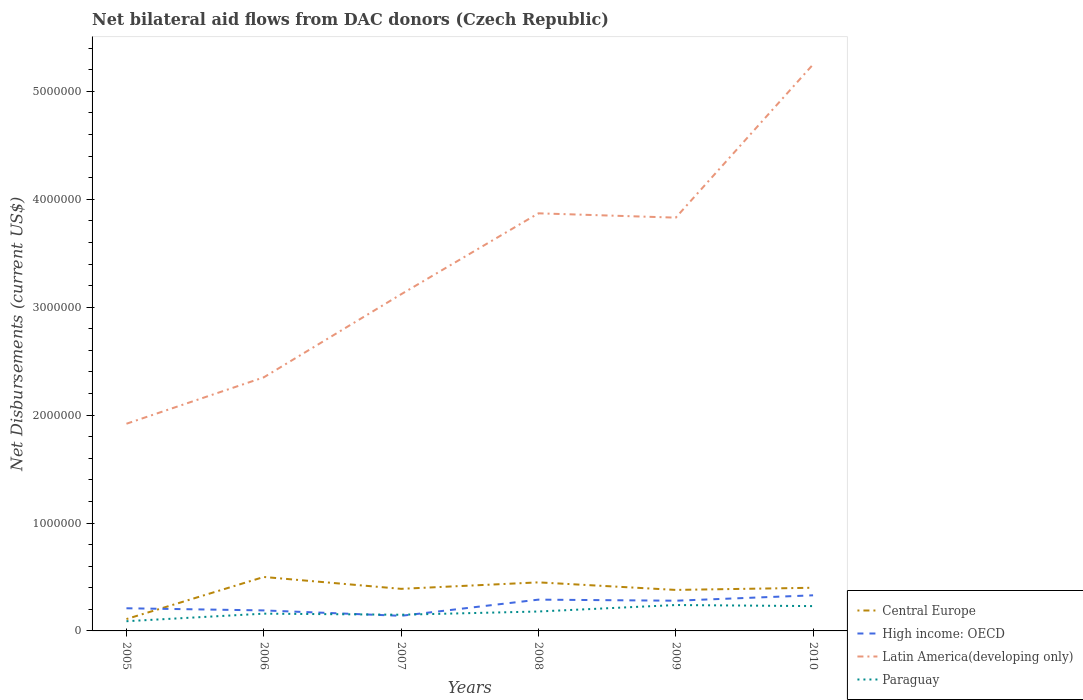How many different coloured lines are there?
Give a very brief answer. 4. Is the number of lines equal to the number of legend labels?
Your answer should be compact. Yes. Across all years, what is the maximum net bilateral aid flows in High income: OECD?
Your answer should be compact. 1.40e+05. What is the total net bilateral aid flows in Latin America(developing only) in the graph?
Offer a very short reply. -1.95e+06. What is the difference between the highest and the lowest net bilateral aid flows in Central Europe?
Your answer should be very brief. 5. Is the net bilateral aid flows in Central Europe strictly greater than the net bilateral aid flows in Latin America(developing only) over the years?
Your answer should be very brief. Yes. Are the values on the major ticks of Y-axis written in scientific E-notation?
Give a very brief answer. No. Does the graph contain any zero values?
Keep it short and to the point. No. Where does the legend appear in the graph?
Give a very brief answer. Bottom right. What is the title of the graph?
Your answer should be compact. Net bilateral aid flows from DAC donors (Czech Republic). What is the label or title of the X-axis?
Ensure brevity in your answer.  Years. What is the label or title of the Y-axis?
Your response must be concise. Net Disbursements (current US$). What is the Net Disbursements (current US$) in High income: OECD in 2005?
Your answer should be very brief. 2.10e+05. What is the Net Disbursements (current US$) in Latin America(developing only) in 2005?
Keep it short and to the point. 1.92e+06. What is the Net Disbursements (current US$) of Paraguay in 2005?
Provide a short and direct response. 9.00e+04. What is the Net Disbursements (current US$) of Latin America(developing only) in 2006?
Provide a short and direct response. 2.35e+06. What is the Net Disbursements (current US$) of Paraguay in 2006?
Your response must be concise. 1.60e+05. What is the Net Disbursements (current US$) in Central Europe in 2007?
Offer a very short reply. 3.90e+05. What is the Net Disbursements (current US$) of Latin America(developing only) in 2007?
Your answer should be very brief. 3.12e+06. What is the Net Disbursements (current US$) of Paraguay in 2007?
Provide a short and direct response. 1.50e+05. What is the Net Disbursements (current US$) in Latin America(developing only) in 2008?
Your answer should be compact. 3.87e+06. What is the Net Disbursements (current US$) in Paraguay in 2008?
Provide a succinct answer. 1.80e+05. What is the Net Disbursements (current US$) of Latin America(developing only) in 2009?
Your answer should be compact. 3.83e+06. What is the Net Disbursements (current US$) in Central Europe in 2010?
Keep it short and to the point. 4.00e+05. What is the Net Disbursements (current US$) of High income: OECD in 2010?
Your answer should be very brief. 3.30e+05. What is the Net Disbursements (current US$) in Latin America(developing only) in 2010?
Provide a succinct answer. 5.25e+06. Across all years, what is the maximum Net Disbursements (current US$) in Latin America(developing only)?
Ensure brevity in your answer.  5.25e+06. Across all years, what is the minimum Net Disbursements (current US$) of High income: OECD?
Your answer should be very brief. 1.40e+05. Across all years, what is the minimum Net Disbursements (current US$) of Latin America(developing only)?
Keep it short and to the point. 1.92e+06. What is the total Net Disbursements (current US$) in Central Europe in the graph?
Offer a very short reply. 2.23e+06. What is the total Net Disbursements (current US$) in High income: OECD in the graph?
Ensure brevity in your answer.  1.44e+06. What is the total Net Disbursements (current US$) in Latin America(developing only) in the graph?
Your answer should be compact. 2.03e+07. What is the total Net Disbursements (current US$) in Paraguay in the graph?
Ensure brevity in your answer.  1.05e+06. What is the difference between the Net Disbursements (current US$) in Central Europe in 2005 and that in 2006?
Make the answer very short. -3.90e+05. What is the difference between the Net Disbursements (current US$) in Latin America(developing only) in 2005 and that in 2006?
Offer a terse response. -4.30e+05. What is the difference between the Net Disbursements (current US$) of Central Europe in 2005 and that in 2007?
Offer a very short reply. -2.80e+05. What is the difference between the Net Disbursements (current US$) of Latin America(developing only) in 2005 and that in 2007?
Offer a terse response. -1.20e+06. What is the difference between the Net Disbursements (current US$) in Paraguay in 2005 and that in 2007?
Provide a succinct answer. -6.00e+04. What is the difference between the Net Disbursements (current US$) of High income: OECD in 2005 and that in 2008?
Ensure brevity in your answer.  -8.00e+04. What is the difference between the Net Disbursements (current US$) of Latin America(developing only) in 2005 and that in 2008?
Offer a terse response. -1.95e+06. What is the difference between the Net Disbursements (current US$) in Paraguay in 2005 and that in 2008?
Provide a succinct answer. -9.00e+04. What is the difference between the Net Disbursements (current US$) in Central Europe in 2005 and that in 2009?
Your answer should be very brief. -2.70e+05. What is the difference between the Net Disbursements (current US$) in High income: OECD in 2005 and that in 2009?
Offer a terse response. -7.00e+04. What is the difference between the Net Disbursements (current US$) of Latin America(developing only) in 2005 and that in 2009?
Provide a short and direct response. -1.91e+06. What is the difference between the Net Disbursements (current US$) in Latin America(developing only) in 2005 and that in 2010?
Your response must be concise. -3.33e+06. What is the difference between the Net Disbursements (current US$) of Central Europe in 2006 and that in 2007?
Your answer should be compact. 1.10e+05. What is the difference between the Net Disbursements (current US$) in Latin America(developing only) in 2006 and that in 2007?
Offer a terse response. -7.70e+05. What is the difference between the Net Disbursements (current US$) in Central Europe in 2006 and that in 2008?
Keep it short and to the point. 5.00e+04. What is the difference between the Net Disbursements (current US$) of Latin America(developing only) in 2006 and that in 2008?
Provide a succinct answer. -1.52e+06. What is the difference between the Net Disbursements (current US$) of Central Europe in 2006 and that in 2009?
Provide a succinct answer. 1.20e+05. What is the difference between the Net Disbursements (current US$) of High income: OECD in 2006 and that in 2009?
Ensure brevity in your answer.  -9.00e+04. What is the difference between the Net Disbursements (current US$) in Latin America(developing only) in 2006 and that in 2009?
Make the answer very short. -1.48e+06. What is the difference between the Net Disbursements (current US$) in Central Europe in 2006 and that in 2010?
Give a very brief answer. 1.00e+05. What is the difference between the Net Disbursements (current US$) of High income: OECD in 2006 and that in 2010?
Your response must be concise. -1.40e+05. What is the difference between the Net Disbursements (current US$) of Latin America(developing only) in 2006 and that in 2010?
Keep it short and to the point. -2.90e+06. What is the difference between the Net Disbursements (current US$) in Paraguay in 2006 and that in 2010?
Your response must be concise. -7.00e+04. What is the difference between the Net Disbursements (current US$) in Latin America(developing only) in 2007 and that in 2008?
Provide a short and direct response. -7.50e+05. What is the difference between the Net Disbursements (current US$) of Central Europe in 2007 and that in 2009?
Your response must be concise. 10000. What is the difference between the Net Disbursements (current US$) in High income: OECD in 2007 and that in 2009?
Give a very brief answer. -1.40e+05. What is the difference between the Net Disbursements (current US$) in Latin America(developing only) in 2007 and that in 2009?
Your answer should be compact. -7.10e+05. What is the difference between the Net Disbursements (current US$) of Latin America(developing only) in 2007 and that in 2010?
Your answer should be very brief. -2.13e+06. What is the difference between the Net Disbursements (current US$) in Paraguay in 2007 and that in 2010?
Provide a succinct answer. -8.00e+04. What is the difference between the Net Disbursements (current US$) in Central Europe in 2008 and that in 2009?
Keep it short and to the point. 7.00e+04. What is the difference between the Net Disbursements (current US$) in High income: OECD in 2008 and that in 2010?
Your response must be concise. -4.00e+04. What is the difference between the Net Disbursements (current US$) of Latin America(developing only) in 2008 and that in 2010?
Make the answer very short. -1.38e+06. What is the difference between the Net Disbursements (current US$) of Paraguay in 2008 and that in 2010?
Make the answer very short. -5.00e+04. What is the difference between the Net Disbursements (current US$) in Central Europe in 2009 and that in 2010?
Offer a very short reply. -2.00e+04. What is the difference between the Net Disbursements (current US$) in Latin America(developing only) in 2009 and that in 2010?
Make the answer very short. -1.42e+06. What is the difference between the Net Disbursements (current US$) of Paraguay in 2009 and that in 2010?
Provide a succinct answer. 10000. What is the difference between the Net Disbursements (current US$) in Central Europe in 2005 and the Net Disbursements (current US$) in Latin America(developing only) in 2006?
Provide a short and direct response. -2.24e+06. What is the difference between the Net Disbursements (current US$) of Central Europe in 2005 and the Net Disbursements (current US$) of Paraguay in 2006?
Offer a terse response. -5.00e+04. What is the difference between the Net Disbursements (current US$) of High income: OECD in 2005 and the Net Disbursements (current US$) of Latin America(developing only) in 2006?
Your answer should be compact. -2.14e+06. What is the difference between the Net Disbursements (current US$) in High income: OECD in 2005 and the Net Disbursements (current US$) in Paraguay in 2006?
Ensure brevity in your answer.  5.00e+04. What is the difference between the Net Disbursements (current US$) of Latin America(developing only) in 2005 and the Net Disbursements (current US$) of Paraguay in 2006?
Give a very brief answer. 1.76e+06. What is the difference between the Net Disbursements (current US$) of Central Europe in 2005 and the Net Disbursements (current US$) of Latin America(developing only) in 2007?
Make the answer very short. -3.01e+06. What is the difference between the Net Disbursements (current US$) of Central Europe in 2005 and the Net Disbursements (current US$) of Paraguay in 2007?
Provide a succinct answer. -4.00e+04. What is the difference between the Net Disbursements (current US$) of High income: OECD in 2005 and the Net Disbursements (current US$) of Latin America(developing only) in 2007?
Ensure brevity in your answer.  -2.91e+06. What is the difference between the Net Disbursements (current US$) in Latin America(developing only) in 2005 and the Net Disbursements (current US$) in Paraguay in 2007?
Provide a short and direct response. 1.77e+06. What is the difference between the Net Disbursements (current US$) of Central Europe in 2005 and the Net Disbursements (current US$) of Latin America(developing only) in 2008?
Provide a succinct answer. -3.76e+06. What is the difference between the Net Disbursements (current US$) in High income: OECD in 2005 and the Net Disbursements (current US$) in Latin America(developing only) in 2008?
Ensure brevity in your answer.  -3.66e+06. What is the difference between the Net Disbursements (current US$) in Latin America(developing only) in 2005 and the Net Disbursements (current US$) in Paraguay in 2008?
Your answer should be very brief. 1.74e+06. What is the difference between the Net Disbursements (current US$) of Central Europe in 2005 and the Net Disbursements (current US$) of Latin America(developing only) in 2009?
Your answer should be very brief. -3.72e+06. What is the difference between the Net Disbursements (current US$) of High income: OECD in 2005 and the Net Disbursements (current US$) of Latin America(developing only) in 2009?
Offer a very short reply. -3.62e+06. What is the difference between the Net Disbursements (current US$) of Latin America(developing only) in 2005 and the Net Disbursements (current US$) of Paraguay in 2009?
Provide a short and direct response. 1.68e+06. What is the difference between the Net Disbursements (current US$) in Central Europe in 2005 and the Net Disbursements (current US$) in High income: OECD in 2010?
Provide a short and direct response. -2.20e+05. What is the difference between the Net Disbursements (current US$) of Central Europe in 2005 and the Net Disbursements (current US$) of Latin America(developing only) in 2010?
Your answer should be very brief. -5.14e+06. What is the difference between the Net Disbursements (current US$) in Central Europe in 2005 and the Net Disbursements (current US$) in Paraguay in 2010?
Provide a succinct answer. -1.20e+05. What is the difference between the Net Disbursements (current US$) of High income: OECD in 2005 and the Net Disbursements (current US$) of Latin America(developing only) in 2010?
Your answer should be compact. -5.04e+06. What is the difference between the Net Disbursements (current US$) of Latin America(developing only) in 2005 and the Net Disbursements (current US$) of Paraguay in 2010?
Provide a succinct answer. 1.69e+06. What is the difference between the Net Disbursements (current US$) of Central Europe in 2006 and the Net Disbursements (current US$) of High income: OECD in 2007?
Ensure brevity in your answer.  3.60e+05. What is the difference between the Net Disbursements (current US$) in Central Europe in 2006 and the Net Disbursements (current US$) in Latin America(developing only) in 2007?
Provide a short and direct response. -2.62e+06. What is the difference between the Net Disbursements (current US$) in High income: OECD in 2006 and the Net Disbursements (current US$) in Latin America(developing only) in 2007?
Offer a terse response. -2.93e+06. What is the difference between the Net Disbursements (current US$) of Latin America(developing only) in 2006 and the Net Disbursements (current US$) of Paraguay in 2007?
Your response must be concise. 2.20e+06. What is the difference between the Net Disbursements (current US$) of Central Europe in 2006 and the Net Disbursements (current US$) of High income: OECD in 2008?
Your response must be concise. 2.10e+05. What is the difference between the Net Disbursements (current US$) of Central Europe in 2006 and the Net Disbursements (current US$) of Latin America(developing only) in 2008?
Give a very brief answer. -3.37e+06. What is the difference between the Net Disbursements (current US$) of Central Europe in 2006 and the Net Disbursements (current US$) of Paraguay in 2008?
Keep it short and to the point. 3.20e+05. What is the difference between the Net Disbursements (current US$) in High income: OECD in 2006 and the Net Disbursements (current US$) in Latin America(developing only) in 2008?
Your response must be concise. -3.68e+06. What is the difference between the Net Disbursements (current US$) in High income: OECD in 2006 and the Net Disbursements (current US$) in Paraguay in 2008?
Your answer should be compact. 10000. What is the difference between the Net Disbursements (current US$) in Latin America(developing only) in 2006 and the Net Disbursements (current US$) in Paraguay in 2008?
Your answer should be very brief. 2.17e+06. What is the difference between the Net Disbursements (current US$) of Central Europe in 2006 and the Net Disbursements (current US$) of High income: OECD in 2009?
Your answer should be compact. 2.20e+05. What is the difference between the Net Disbursements (current US$) of Central Europe in 2006 and the Net Disbursements (current US$) of Latin America(developing only) in 2009?
Your answer should be compact. -3.33e+06. What is the difference between the Net Disbursements (current US$) of High income: OECD in 2006 and the Net Disbursements (current US$) of Latin America(developing only) in 2009?
Make the answer very short. -3.64e+06. What is the difference between the Net Disbursements (current US$) in High income: OECD in 2006 and the Net Disbursements (current US$) in Paraguay in 2009?
Offer a very short reply. -5.00e+04. What is the difference between the Net Disbursements (current US$) of Latin America(developing only) in 2006 and the Net Disbursements (current US$) of Paraguay in 2009?
Make the answer very short. 2.11e+06. What is the difference between the Net Disbursements (current US$) in Central Europe in 2006 and the Net Disbursements (current US$) in High income: OECD in 2010?
Offer a very short reply. 1.70e+05. What is the difference between the Net Disbursements (current US$) of Central Europe in 2006 and the Net Disbursements (current US$) of Latin America(developing only) in 2010?
Keep it short and to the point. -4.75e+06. What is the difference between the Net Disbursements (current US$) in High income: OECD in 2006 and the Net Disbursements (current US$) in Latin America(developing only) in 2010?
Ensure brevity in your answer.  -5.06e+06. What is the difference between the Net Disbursements (current US$) in High income: OECD in 2006 and the Net Disbursements (current US$) in Paraguay in 2010?
Provide a short and direct response. -4.00e+04. What is the difference between the Net Disbursements (current US$) in Latin America(developing only) in 2006 and the Net Disbursements (current US$) in Paraguay in 2010?
Provide a short and direct response. 2.12e+06. What is the difference between the Net Disbursements (current US$) in Central Europe in 2007 and the Net Disbursements (current US$) in High income: OECD in 2008?
Make the answer very short. 1.00e+05. What is the difference between the Net Disbursements (current US$) in Central Europe in 2007 and the Net Disbursements (current US$) in Latin America(developing only) in 2008?
Give a very brief answer. -3.48e+06. What is the difference between the Net Disbursements (current US$) of High income: OECD in 2007 and the Net Disbursements (current US$) of Latin America(developing only) in 2008?
Your response must be concise. -3.73e+06. What is the difference between the Net Disbursements (current US$) in Latin America(developing only) in 2007 and the Net Disbursements (current US$) in Paraguay in 2008?
Give a very brief answer. 2.94e+06. What is the difference between the Net Disbursements (current US$) of Central Europe in 2007 and the Net Disbursements (current US$) of High income: OECD in 2009?
Your answer should be very brief. 1.10e+05. What is the difference between the Net Disbursements (current US$) in Central Europe in 2007 and the Net Disbursements (current US$) in Latin America(developing only) in 2009?
Keep it short and to the point. -3.44e+06. What is the difference between the Net Disbursements (current US$) in Central Europe in 2007 and the Net Disbursements (current US$) in Paraguay in 2009?
Provide a succinct answer. 1.50e+05. What is the difference between the Net Disbursements (current US$) of High income: OECD in 2007 and the Net Disbursements (current US$) of Latin America(developing only) in 2009?
Give a very brief answer. -3.69e+06. What is the difference between the Net Disbursements (current US$) in Latin America(developing only) in 2007 and the Net Disbursements (current US$) in Paraguay in 2009?
Your response must be concise. 2.88e+06. What is the difference between the Net Disbursements (current US$) of Central Europe in 2007 and the Net Disbursements (current US$) of Latin America(developing only) in 2010?
Offer a terse response. -4.86e+06. What is the difference between the Net Disbursements (current US$) of High income: OECD in 2007 and the Net Disbursements (current US$) of Latin America(developing only) in 2010?
Provide a succinct answer. -5.11e+06. What is the difference between the Net Disbursements (current US$) in High income: OECD in 2007 and the Net Disbursements (current US$) in Paraguay in 2010?
Your response must be concise. -9.00e+04. What is the difference between the Net Disbursements (current US$) of Latin America(developing only) in 2007 and the Net Disbursements (current US$) of Paraguay in 2010?
Your answer should be very brief. 2.89e+06. What is the difference between the Net Disbursements (current US$) of Central Europe in 2008 and the Net Disbursements (current US$) of Latin America(developing only) in 2009?
Offer a terse response. -3.38e+06. What is the difference between the Net Disbursements (current US$) in High income: OECD in 2008 and the Net Disbursements (current US$) in Latin America(developing only) in 2009?
Make the answer very short. -3.54e+06. What is the difference between the Net Disbursements (current US$) of High income: OECD in 2008 and the Net Disbursements (current US$) of Paraguay in 2009?
Ensure brevity in your answer.  5.00e+04. What is the difference between the Net Disbursements (current US$) of Latin America(developing only) in 2008 and the Net Disbursements (current US$) of Paraguay in 2009?
Provide a succinct answer. 3.63e+06. What is the difference between the Net Disbursements (current US$) in Central Europe in 2008 and the Net Disbursements (current US$) in High income: OECD in 2010?
Offer a very short reply. 1.20e+05. What is the difference between the Net Disbursements (current US$) of Central Europe in 2008 and the Net Disbursements (current US$) of Latin America(developing only) in 2010?
Offer a terse response. -4.80e+06. What is the difference between the Net Disbursements (current US$) of Central Europe in 2008 and the Net Disbursements (current US$) of Paraguay in 2010?
Your response must be concise. 2.20e+05. What is the difference between the Net Disbursements (current US$) in High income: OECD in 2008 and the Net Disbursements (current US$) in Latin America(developing only) in 2010?
Offer a very short reply. -4.96e+06. What is the difference between the Net Disbursements (current US$) in Latin America(developing only) in 2008 and the Net Disbursements (current US$) in Paraguay in 2010?
Your answer should be compact. 3.64e+06. What is the difference between the Net Disbursements (current US$) of Central Europe in 2009 and the Net Disbursements (current US$) of Latin America(developing only) in 2010?
Your answer should be very brief. -4.87e+06. What is the difference between the Net Disbursements (current US$) in Central Europe in 2009 and the Net Disbursements (current US$) in Paraguay in 2010?
Provide a succinct answer. 1.50e+05. What is the difference between the Net Disbursements (current US$) in High income: OECD in 2009 and the Net Disbursements (current US$) in Latin America(developing only) in 2010?
Your answer should be compact. -4.97e+06. What is the difference between the Net Disbursements (current US$) in Latin America(developing only) in 2009 and the Net Disbursements (current US$) in Paraguay in 2010?
Provide a succinct answer. 3.60e+06. What is the average Net Disbursements (current US$) of Central Europe per year?
Offer a terse response. 3.72e+05. What is the average Net Disbursements (current US$) in Latin America(developing only) per year?
Ensure brevity in your answer.  3.39e+06. What is the average Net Disbursements (current US$) of Paraguay per year?
Your answer should be compact. 1.75e+05. In the year 2005, what is the difference between the Net Disbursements (current US$) in Central Europe and Net Disbursements (current US$) in Latin America(developing only)?
Your response must be concise. -1.81e+06. In the year 2005, what is the difference between the Net Disbursements (current US$) of High income: OECD and Net Disbursements (current US$) of Latin America(developing only)?
Offer a terse response. -1.71e+06. In the year 2005, what is the difference between the Net Disbursements (current US$) in Latin America(developing only) and Net Disbursements (current US$) in Paraguay?
Provide a short and direct response. 1.83e+06. In the year 2006, what is the difference between the Net Disbursements (current US$) in Central Europe and Net Disbursements (current US$) in High income: OECD?
Your answer should be very brief. 3.10e+05. In the year 2006, what is the difference between the Net Disbursements (current US$) of Central Europe and Net Disbursements (current US$) of Latin America(developing only)?
Offer a terse response. -1.85e+06. In the year 2006, what is the difference between the Net Disbursements (current US$) in Central Europe and Net Disbursements (current US$) in Paraguay?
Provide a succinct answer. 3.40e+05. In the year 2006, what is the difference between the Net Disbursements (current US$) of High income: OECD and Net Disbursements (current US$) of Latin America(developing only)?
Ensure brevity in your answer.  -2.16e+06. In the year 2006, what is the difference between the Net Disbursements (current US$) in High income: OECD and Net Disbursements (current US$) in Paraguay?
Your answer should be very brief. 3.00e+04. In the year 2006, what is the difference between the Net Disbursements (current US$) in Latin America(developing only) and Net Disbursements (current US$) in Paraguay?
Keep it short and to the point. 2.19e+06. In the year 2007, what is the difference between the Net Disbursements (current US$) in Central Europe and Net Disbursements (current US$) in High income: OECD?
Keep it short and to the point. 2.50e+05. In the year 2007, what is the difference between the Net Disbursements (current US$) in Central Europe and Net Disbursements (current US$) in Latin America(developing only)?
Keep it short and to the point. -2.73e+06. In the year 2007, what is the difference between the Net Disbursements (current US$) of High income: OECD and Net Disbursements (current US$) of Latin America(developing only)?
Your response must be concise. -2.98e+06. In the year 2007, what is the difference between the Net Disbursements (current US$) in High income: OECD and Net Disbursements (current US$) in Paraguay?
Give a very brief answer. -10000. In the year 2007, what is the difference between the Net Disbursements (current US$) of Latin America(developing only) and Net Disbursements (current US$) of Paraguay?
Offer a terse response. 2.97e+06. In the year 2008, what is the difference between the Net Disbursements (current US$) of Central Europe and Net Disbursements (current US$) of Latin America(developing only)?
Provide a short and direct response. -3.42e+06. In the year 2008, what is the difference between the Net Disbursements (current US$) in Central Europe and Net Disbursements (current US$) in Paraguay?
Your answer should be compact. 2.70e+05. In the year 2008, what is the difference between the Net Disbursements (current US$) in High income: OECD and Net Disbursements (current US$) in Latin America(developing only)?
Make the answer very short. -3.58e+06. In the year 2008, what is the difference between the Net Disbursements (current US$) of Latin America(developing only) and Net Disbursements (current US$) of Paraguay?
Keep it short and to the point. 3.69e+06. In the year 2009, what is the difference between the Net Disbursements (current US$) in Central Europe and Net Disbursements (current US$) in High income: OECD?
Keep it short and to the point. 1.00e+05. In the year 2009, what is the difference between the Net Disbursements (current US$) of Central Europe and Net Disbursements (current US$) of Latin America(developing only)?
Give a very brief answer. -3.45e+06. In the year 2009, what is the difference between the Net Disbursements (current US$) in High income: OECD and Net Disbursements (current US$) in Latin America(developing only)?
Ensure brevity in your answer.  -3.55e+06. In the year 2009, what is the difference between the Net Disbursements (current US$) of Latin America(developing only) and Net Disbursements (current US$) of Paraguay?
Your answer should be very brief. 3.59e+06. In the year 2010, what is the difference between the Net Disbursements (current US$) of Central Europe and Net Disbursements (current US$) of High income: OECD?
Your answer should be very brief. 7.00e+04. In the year 2010, what is the difference between the Net Disbursements (current US$) in Central Europe and Net Disbursements (current US$) in Latin America(developing only)?
Give a very brief answer. -4.85e+06. In the year 2010, what is the difference between the Net Disbursements (current US$) in High income: OECD and Net Disbursements (current US$) in Latin America(developing only)?
Give a very brief answer. -4.92e+06. In the year 2010, what is the difference between the Net Disbursements (current US$) in High income: OECD and Net Disbursements (current US$) in Paraguay?
Offer a very short reply. 1.00e+05. In the year 2010, what is the difference between the Net Disbursements (current US$) in Latin America(developing only) and Net Disbursements (current US$) in Paraguay?
Offer a terse response. 5.02e+06. What is the ratio of the Net Disbursements (current US$) of Central Europe in 2005 to that in 2006?
Provide a succinct answer. 0.22. What is the ratio of the Net Disbursements (current US$) of High income: OECD in 2005 to that in 2006?
Make the answer very short. 1.11. What is the ratio of the Net Disbursements (current US$) of Latin America(developing only) in 2005 to that in 2006?
Give a very brief answer. 0.82. What is the ratio of the Net Disbursements (current US$) of Paraguay in 2005 to that in 2006?
Offer a terse response. 0.56. What is the ratio of the Net Disbursements (current US$) in Central Europe in 2005 to that in 2007?
Your answer should be very brief. 0.28. What is the ratio of the Net Disbursements (current US$) of High income: OECD in 2005 to that in 2007?
Your answer should be very brief. 1.5. What is the ratio of the Net Disbursements (current US$) in Latin America(developing only) in 2005 to that in 2007?
Your answer should be compact. 0.62. What is the ratio of the Net Disbursements (current US$) of Central Europe in 2005 to that in 2008?
Provide a short and direct response. 0.24. What is the ratio of the Net Disbursements (current US$) of High income: OECD in 2005 to that in 2008?
Provide a short and direct response. 0.72. What is the ratio of the Net Disbursements (current US$) of Latin America(developing only) in 2005 to that in 2008?
Your answer should be very brief. 0.5. What is the ratio of the Net Disbursements (current US$) in Paraguay in 2005 to that in 2008?
Provide a short and direct response. 0.5. What is the ratio of the Net Disbursements (current US$) in Central Europe in 2005 to that in 2009?
Ensure brevity in your answer.  0.29. What is the ratio of the Net Disbursements (current US$) of Latin America(developing only) in 2005 to that in 2009?
Provide a short and direct response. 0.5. What is the ratio of the Net Disbursements (current US$) of Central Europe in 2005 to that in 2010?
Offer a terse response. 0.28. What is the ratio of the Net Disbursements (current US$) in High income: OECD in 2005 to that in 2010?
Make the answer very short. 0.64. What is the ratio of the Net Disbursements (current US$) of Latin America(developing only) in 2005 to that in 2010?
Your response must be concise. 0.37. What is the ratio of the Net Disbursements (current US$) of Paraguay in 2005 to that in 2010?
Offer a very short reply. 0.39. What is the ratio of the Net Disbursements (current US$) of Central Europe in 2006 to that in 2007?
Provide a succinct answer. 1.28. What is the ratio of the Net Disbursements (current US$) in High income: OECD in 2006 to that in 2007?
Offer a terse response. 1.36. What is the ratio of the Net Disbursements (current US$) in Latin America(developing only) in 2006 to that in 2007?
Make the answer very short. 0.75. What is the ratio of the Net Disbursements (current US$) in Paraguay in 2006 to that in 2007?
Your response must be concise. 1.07. What is the ratio of the Net Disbursements (current US$) of High income: OECD in 2006 to that in 2008?
Give a very brief answer. 0.66. What is the ratio of the Net Disbursements (current US$) in Latin America(developing only) in 2006 to that in 2008?
Your answer should be compact. 0.61. What is the ratio of the Net Disbursements (current US$) of Paraguay in 2006 to that in 2008?
Your response must be concise. 0.89. What is the ratio of the Net Disbursements (current US$) of Central Europe in 2006 to that in 2009?
Your response must be concise. 1.32. What is the ratio of the Net Disbursements (current US$) in High income: OECD in 2006 to that in 2009?
Your response must be concise. 0.68. What is the ratio of the Net Disbursements (current US$) in Latin America(developing only) in 2006 to that in 2009?
Provide a short and direct response. 0.61. What is the ratio of the Net Disbursements (current US$) in High income: OECD in 2006 to that in 2010?
Your answer should be compact. 0.58. What is the ratio of the Net Disbursements (current US$) of Latin America(developing only) in 2006 to that in 2010?
Your answer should be compact. 0.45. What is the ratio of the Net Disbursements (current US$) in Paraguay in 2006 to that in 2010?
Provide a succinct answer. 0.7. What is the ratio of the Net Disbursements (current US$) in Central Europe in 2007 to that in 2008?
Offer a terse response. 0.87. What is the ratio of the Net Disbursements (current US$) in High income: OECD in 2007 to that in 2008?
Provide a short and direct response. 0.48. What is the ratio of the Net Disbursements (current US$) in Latin America(developing only) in 2007 to that in 2008?
Ensure brevity in your answer.  0.81. What is the ratio of the Net Disbursements (current US$) of Central Europe in 2007 to that in 2009?
Make the answer very short. 1.03. What is the ratio of the Net Disbursements (current US$) of Latin America(developing only) in 2007 to that in 2009?
Provide a short and direct response. 0.81. What is the ratio of the Net Disbursements (current US$) of Paraguay in 2007 to that in 2009?
Your response must be concise. 0.62. What is the ratio of the Net Disbursements (current US$) of High income: OECD in 2007 to that in 2010?
Offer a very short reply. 0.42. What is the ratio of the Net Disbursements (current US$) of Latin America(developing only) in 2007 to that in 2010?
Your answer should be compact. 0.59. What is the ratio of the Net Disbursements (current US$) of Paraguay in 2007 to that in 2010?
Provide a short and direct response. 0.65. What is the ratio of the Net Disbursements (current US$) in Central Europe in 2008 to that in 2009?
Offer a terse response. 1.18. What is the ratio of the Net Disbursements (current US$) of High income: OECD in 2008 to that in 2009?
Make the answer very short. 1.04. What is the ratio of the Net Disbursements (current US$) in Latin America(developing only) in 2008 to that in 2009?
Your response must be concise. 1.01. What is the ratio of the Net Disbursements (current US$) in Central Europe in 2008 to that in 2010?
Your answer should be compact. 1.12. What is the ratio of the Net Disbursements (current US$) in High income: OECD in 2008 to that in 2010?
Keep it short and to the point. 0.88. What is the ratio of the Net Disbursements (current US$) in Latin America(developing only) in 2008 to that in 2010?
Your response must be concise. 0.74. What is the ratio of the Net Disbursements (current US$) in Paraguay in 2008 to that in 2010?
Provide a succinct answer. 0.78. What is the ratio of the Net Disbursements (current US$) in High income: OECD in 2009 to that in 2010?
Your answer should be very brief. 0.85. What is the ratio of the Net Disbursements (current US$) of Latin America(developing only) in 2009 to that in 2010?
Provide a succinct answer. 0.73. What is the ratio of the Net Disbursements (current US$) in Paraguay in 2009 to that in 2010?
Make the answer very short. 1.04. What is the difference between the highest and the second highest Net Disbursements (current US$) of High income: OECD?
Your response must be concise. 4.00e+04. What is the difference between the highest and the second highest Net Disbursements (current US$) in Latin America(developing only)?
Give a very brief answer. 1.38e+06. What is the difference between the highest and the second highest Net Disbursements (current US$) in Paraguay?
Keep it short and to the point. 10000. What is the difference between the highest and the lowest Net Disbursements (current US$) of High income: OECD?
Your response must be concise. 1.90e+05. What is the difference between the highest and the lowest Net Disbursements (current US$) of Latin America(developing only)?
Provide a short and direct response. 3.33e+06. What is the difference between the highest and the lowest Net Disbursements (current US$) of Paraguay?
Provide a succinct answer. 1.50e+05. 